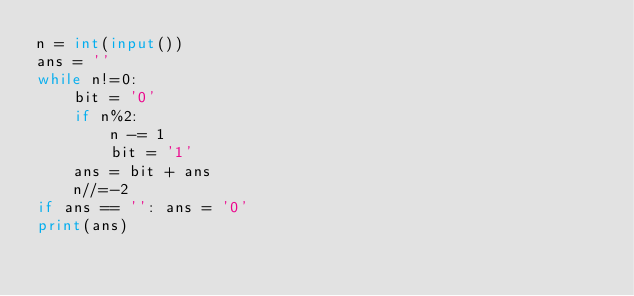<code> <loc_0><loc_0><loc_500><loc_500><_Python_>n = int(input())
ans = ''
while n!=0:
    bit = '0'
    if n%2:
        n -= 1
        bit = '1'
    ans = bit + ans
    n//=-2
if ans == '': ans = '0'
print(ans)
</code> 